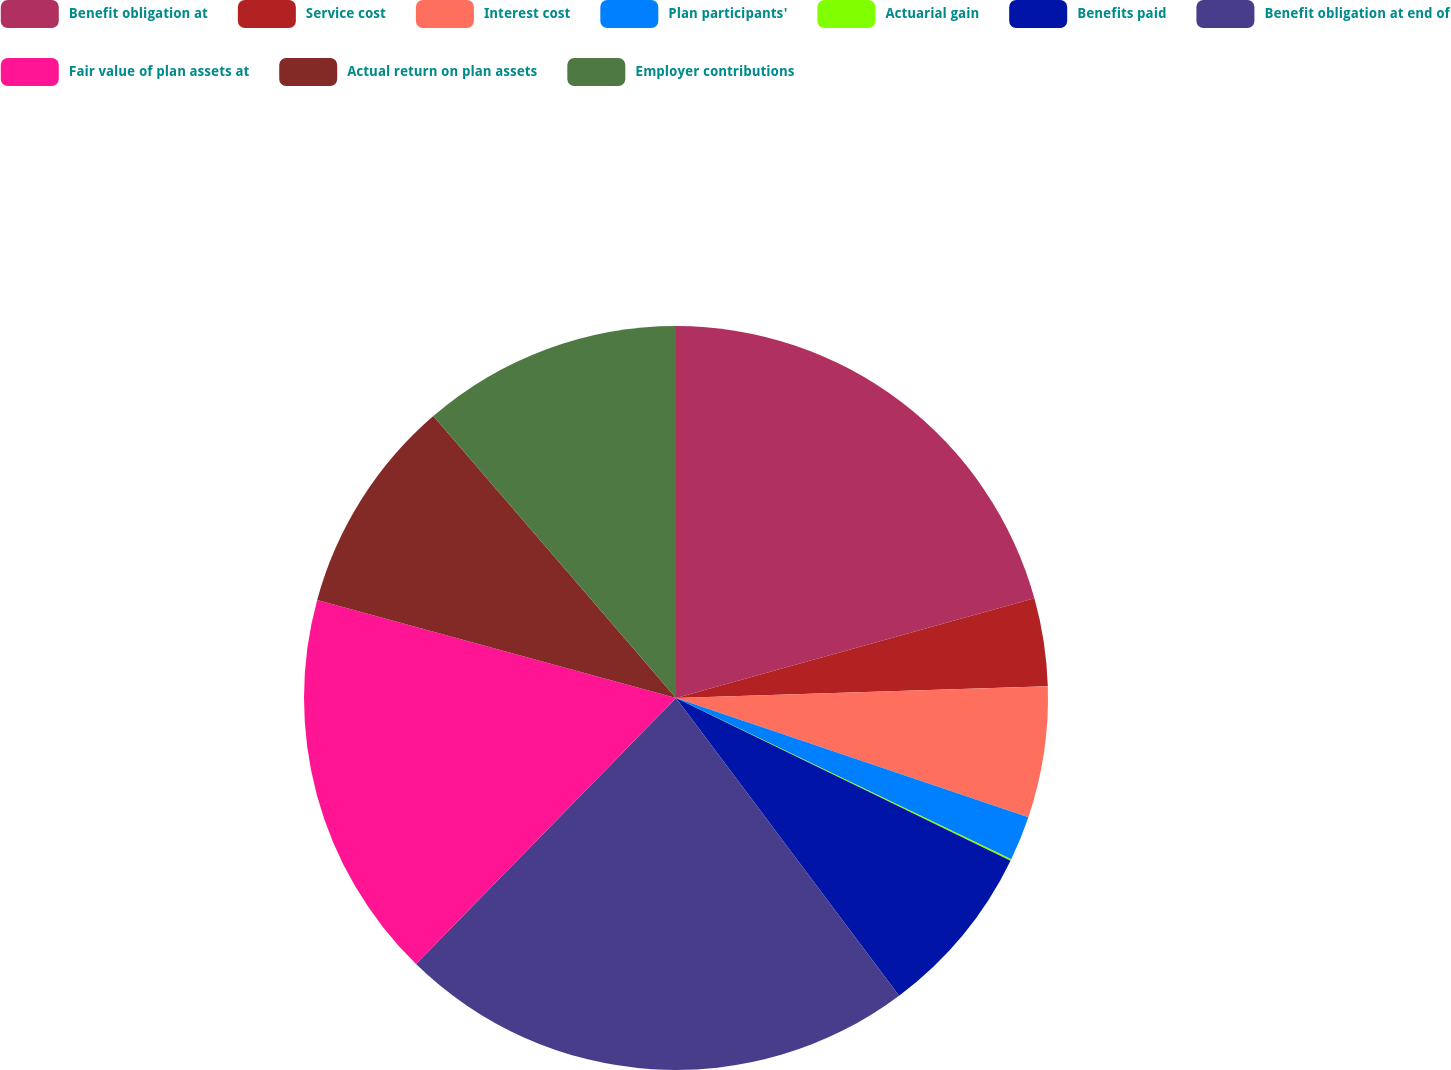Convert chart to OTSL. <chart><loc_0><loc_0><loc_500><loc_500><pie_chart><fcel>Benefit obligation at<fcel>Service cost<fcel>Interest cost<fcel>Plan participants'<fcel>Actuarial gain<fcel>Benefits paid<fcel>Benefit obligation at end of<fcel>Fair value of plan assets at<fcel>Actual return on plan assets<fcel>Employer contributions<nl><fcel>20.68%<fcel>3.82%<fcel>5.69%<fcel>1.94%<fcel>0.07%<fcel>7.56%<fcel>22.55%<fcel>16.93%<fcel>9.44%<fcel>11.31%<nl></chart> 